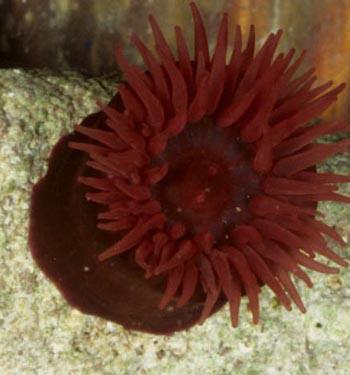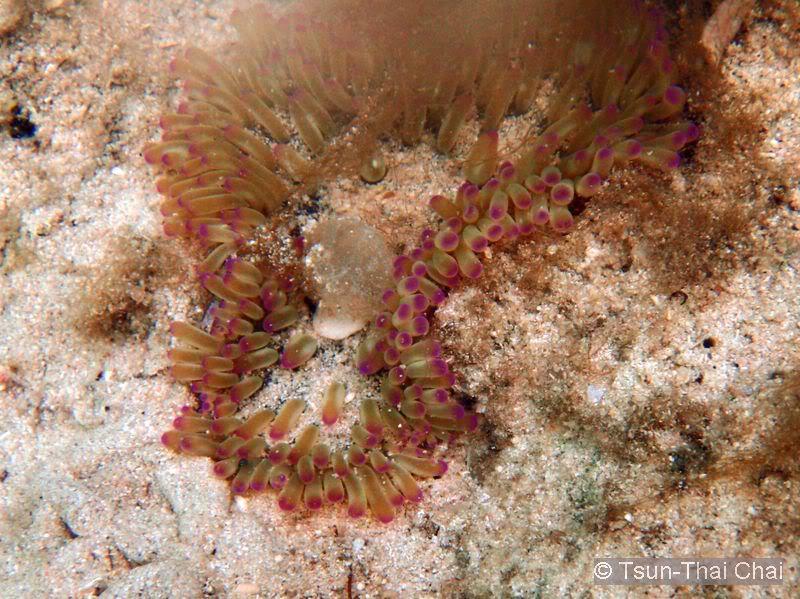The first image is the image on the left, the second image is the image on the right. Evaluate the accuracy of this statement regarding the images: "One of the images has more than three anemones visible.". Is it true? Answer yes or no. No. 